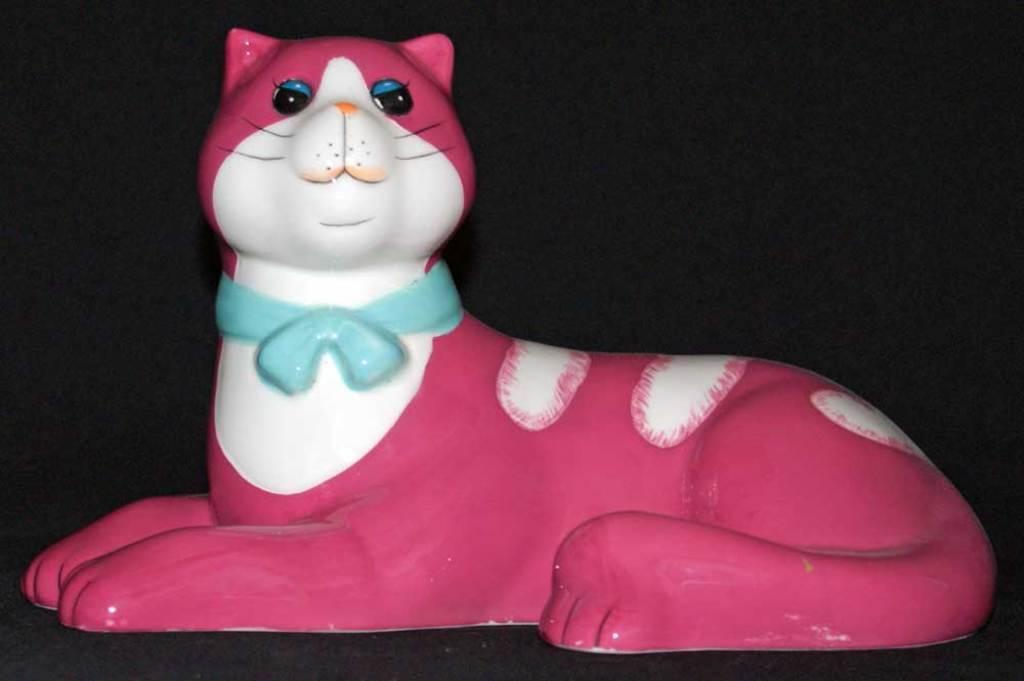How would you summarize this image in a sentence or two? In this image I can see a sculpture of a cat in the front. I can see colour of the cat is pink, white and blue. I can also see black colour in the background. 